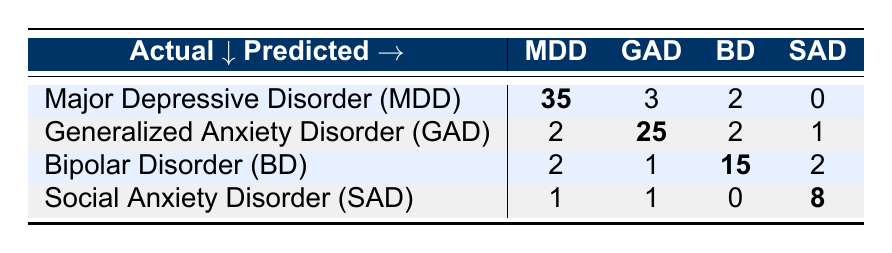What is the number of true positives for Major Depressive Disorder? Referring to the table, the number of true positives for Major Depressive Disorder (MDD) is directly given as 35.
Answer: 35 What is the total number of patients diagnosed with Generalized Anxiety Disorder? The total number of patients diagnosed with Generalized Anxiety Disorder (GAD) is the sum of true positives (25), false positives (5), and false negatives (5), which equals 25 + 5 + 5 = 35.
Answer: 35 Is there a higher number of false positives for Bipolar Disorder compared to Social Anxiety Disorder? For Bipolar Disorder (BD), there are 5 false positives and for Social Anxiety Disorder (SAD), there are 2. Since 5 is greater than 2, the statement is true.
Answer: Yes What is the total number of false negatives across all disorders? To find the total number of false negatives, we add the false negatives for each disorder: MDD (5) + GAD (5) + BD (5) + SAD (0) = 5 + 5 + 5 + 0 = 15.
Answer: 15 How many fewer true positives does Social Anxiety Disorder have compared to Major Depressive Disorder? The true positives for Social Anxiety Disorder (SAD) is 8 and for Major Depressive Disorder (MDD) it's 35. The difference is 35 - 8 = 27 fewer true positives.
Answer: 27 What percentage of patients diagnosed with Bipolar Disorder were classified correctly? The total diagnosed with Bipolar Disorder includes 15 true positives and 5 false negatives, making a total of 20. The percentage classified correctly is (15/20) × 100 = 75%.
Answer: 75% Does Generalized Anxiety Disorder have more true positives than Social Anxiety Disorder? The number of true positives for Generalized Anxiety Disorder (GAD) is 25, while for Social Anxiety Disorder (SAD) it is 8. Since 25 is greater than 8, the statement is true.
Answer: Yes What is the total number of patients predicted to have Major Depressive Disorder? The total for predicted Major Depressive Disorder includes true positives (35) and false positives (3). So, 35 + 3 = 38 predicted to have MDD.
Answer: 38 